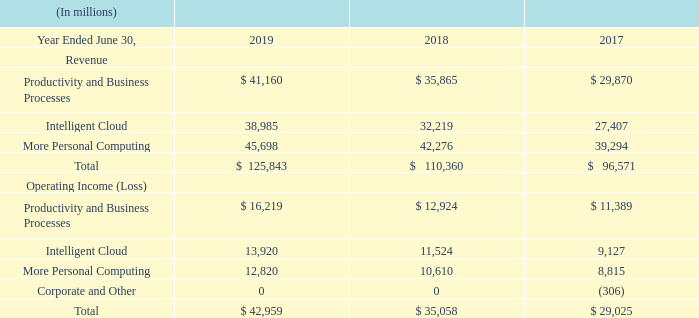Revenue and costs are generally directly attributed to our segments. However, due to the integrated structure of our business, certain revenue recognized and costs incurred by one segment may benefit other segments. Revenue from certain contracts is allocated among the segments based on the relative value of the underlying products and services, which can include allocation based on actual prices charged, prices when sold separately, or estimated costs plus a profit margin. Cost of revenue is allocated in certain cases based on a relative revenue methodology. Operating expenses that are allocated primarily include those relating to marketing of products and services from which multiple segments benefit and are generally allocated based on relative gross margin.
In addition, certain costs incurred at a corporate level that are identifiable and that benefit our segments are allocated to them. These allocated costs include costs of: legal, including settlements and fines; information technology; human resources; finance; excise taxes; field selling; shared facilities services; and customer service and support. Each allocation is measured differently based on the specific facts and circumstances of the costs being allocated. Certain corporate-level activity is not allocated to our segments, including restructuring expenses.
Segment revenue and operating income were as follows during the periods presented:
Corporate and Other operating loss comprised restructuring expenses.
How is the revenue from certain contracts allocated? Revenue from certain contracts is allocated among the segments based on the relative value of the underlying products and services, which can include allocation based on actual prices charged, prices when sold separately, or estimated costs plus a profit margin. How are operating expenses generally allocated? Operating expenses that are allocated primarily include those relating to marketing of products and services from which multiple segments benefit and are generally allocated based on relative gross margin. What do the allocated costs include? These allocated costs include costs of: legal, including settlements and fines; information technology; human resources; finance; excise taxes; field selling; shared facilities services; and customer service and support. Which of the 3 years from 2017 to 2019 had the highest revenue for Intelligent Cloud? 38,985 > 32,219 > 27,407
Answer: 2019. How many items are there for operating income (loss)? Productivity and Business Processes## Intelligent Cloud## More Personal Computing## Corporate and Other
Answer: 4. How many of the 3 years from 2017 to 2019 had operating income of less than $14,000 million for productivity and business processes? 12,924##11,389
Answer: 2. 